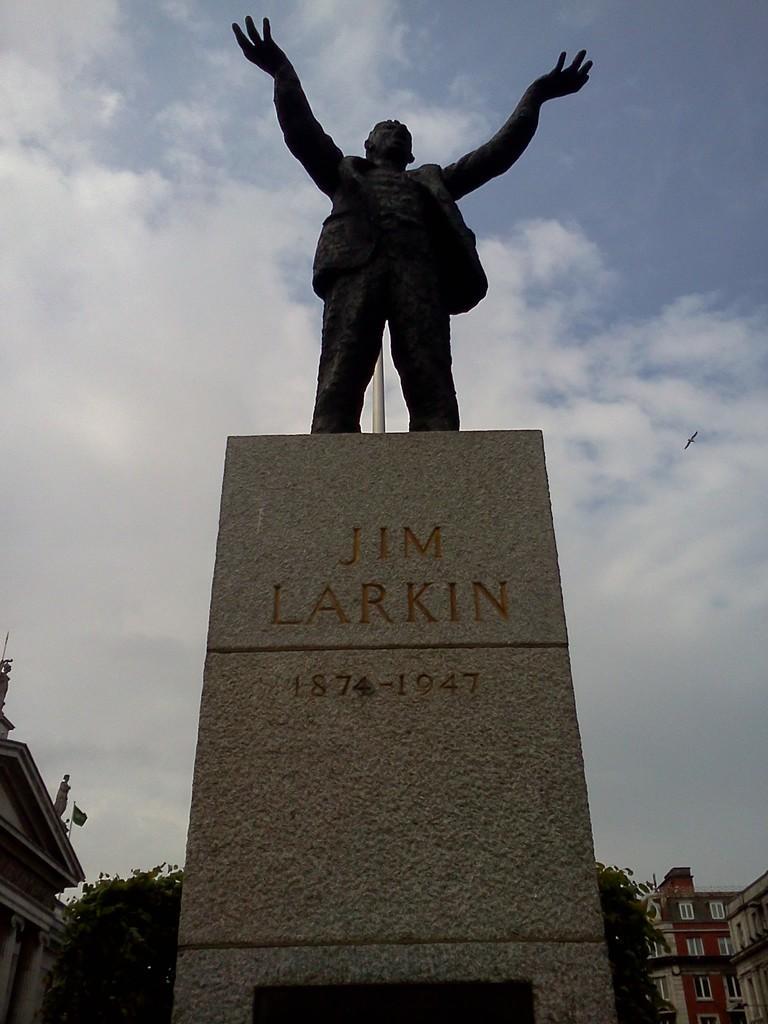Can you describe this image briefly? In this image I can see a sculpture of a person. In the background I can see number of buildings and number of trees. I can also see clear view of sky. 